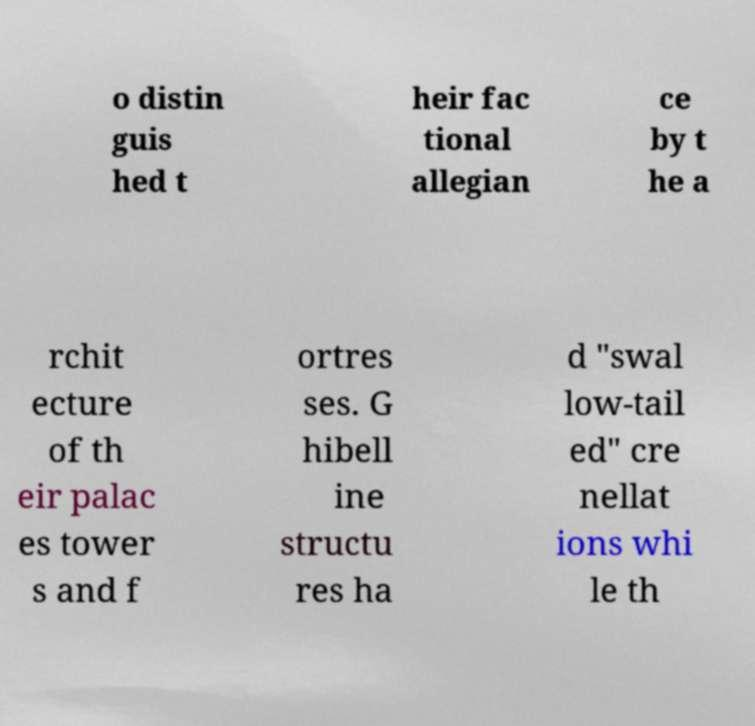Could you extract and type out the text from this image? o distin guis hed t heir fac tional allegian ce by t he a rchit ecture of th eir palac es tower s and f ortres ses. G hibell ine structu res ha d "swal low-tail ed" cre nellat ions whi le th 